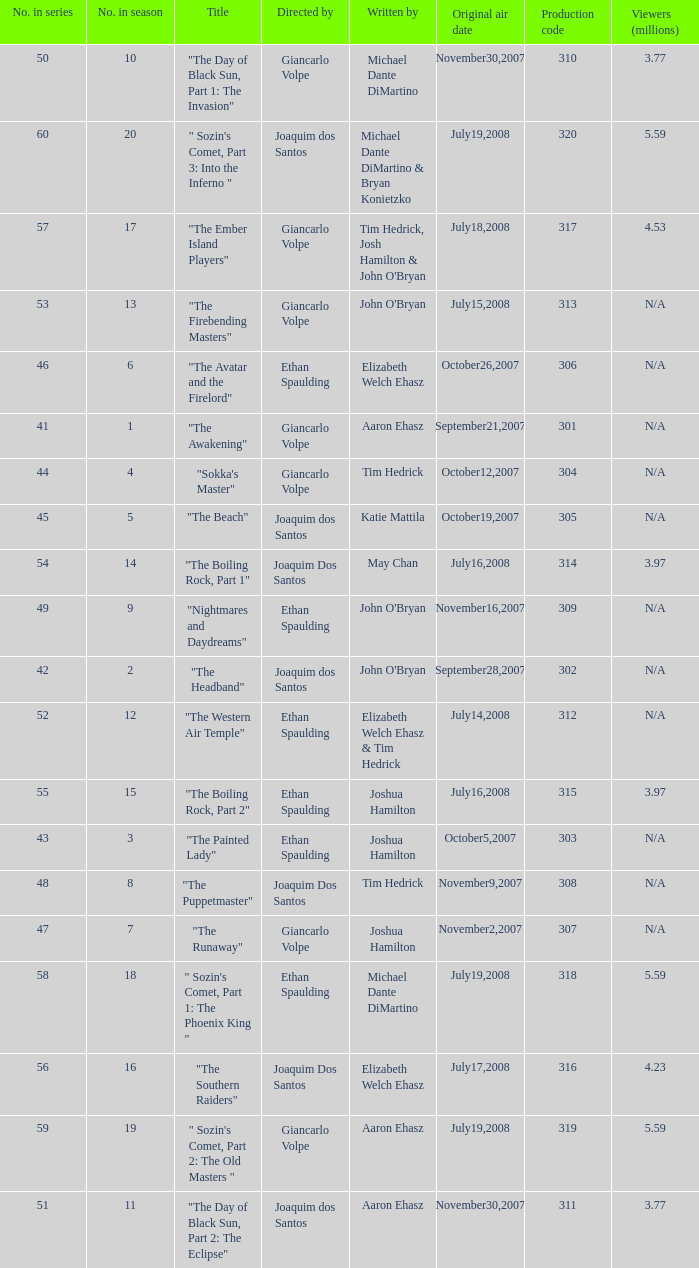What is the original air date for the episode with a production code of 318? July19,2008. 